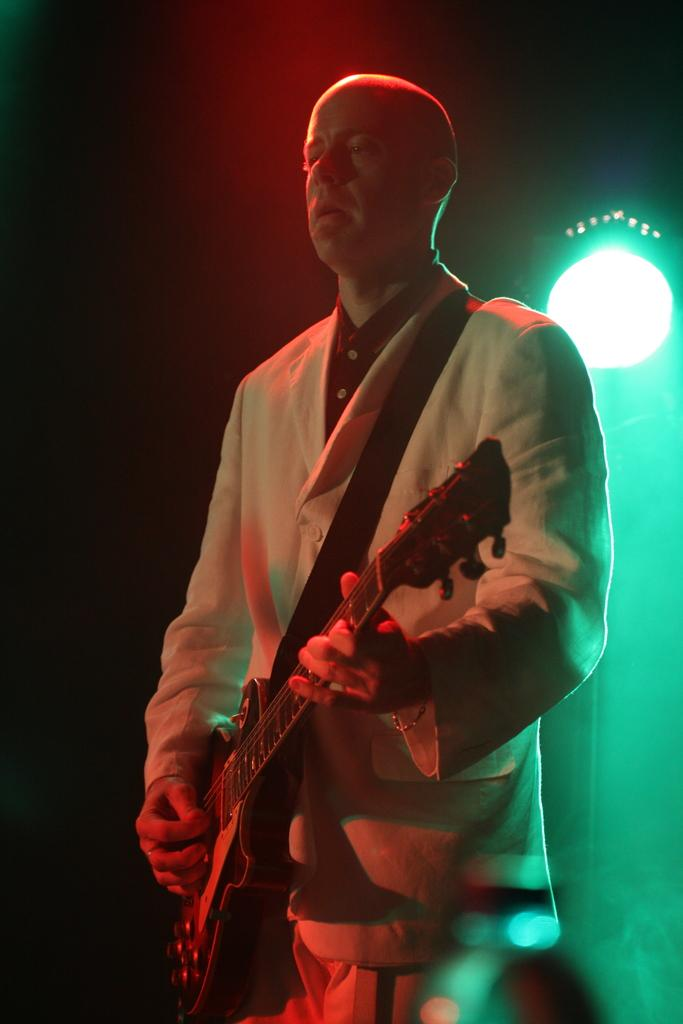What is the main subject of the image? The main subject of the image is a man. What is the man holding in the image? The man is holding a guitar. What type of shade is being provided by the guitar in the image? There is no shade being provided by the guitar in the image, as it is a musical instrument and not a source of shade. 